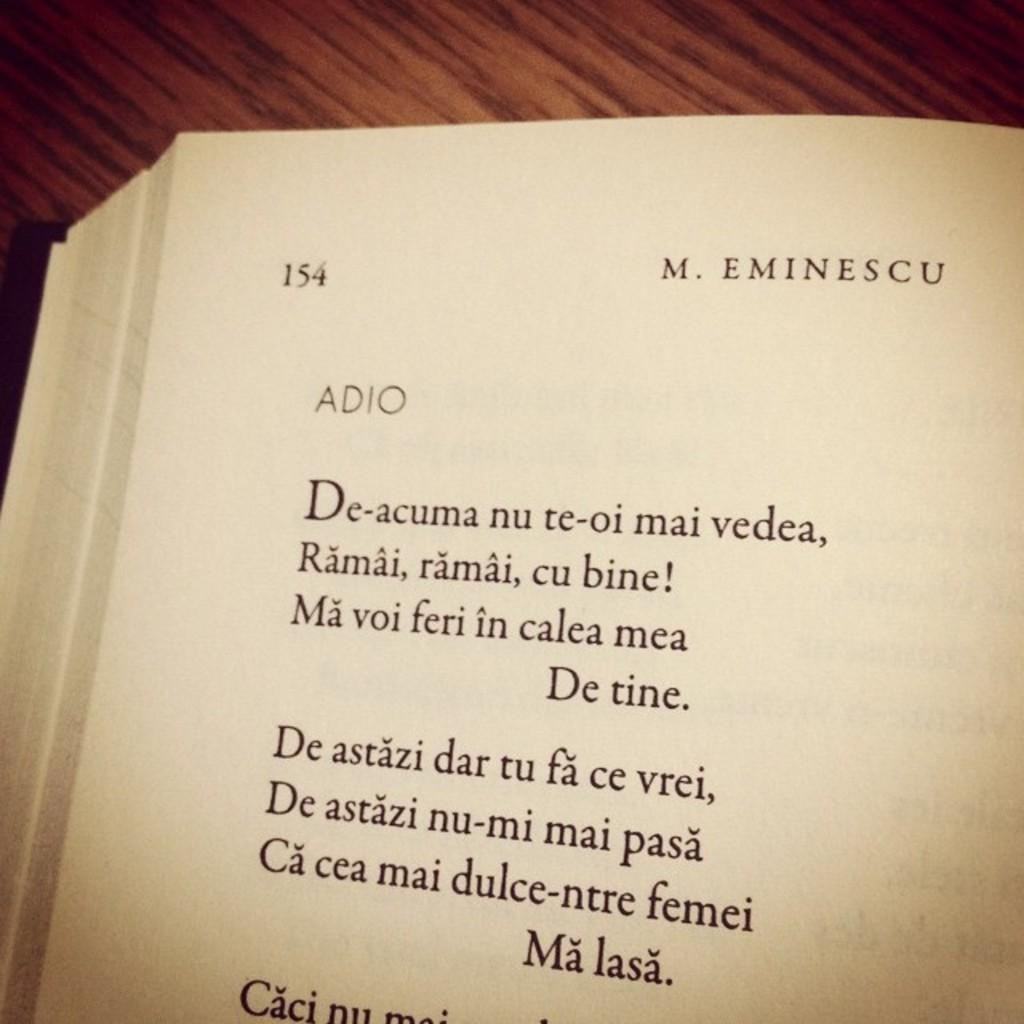<image>
Share a concise interpretation of the image provided. Page 154 from a book by M. Eminescu contains the poem Adio. 